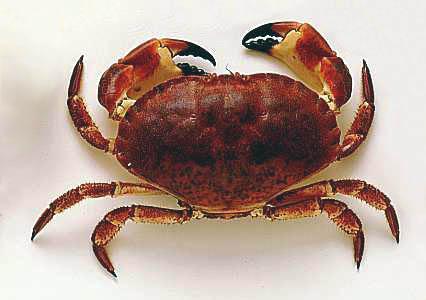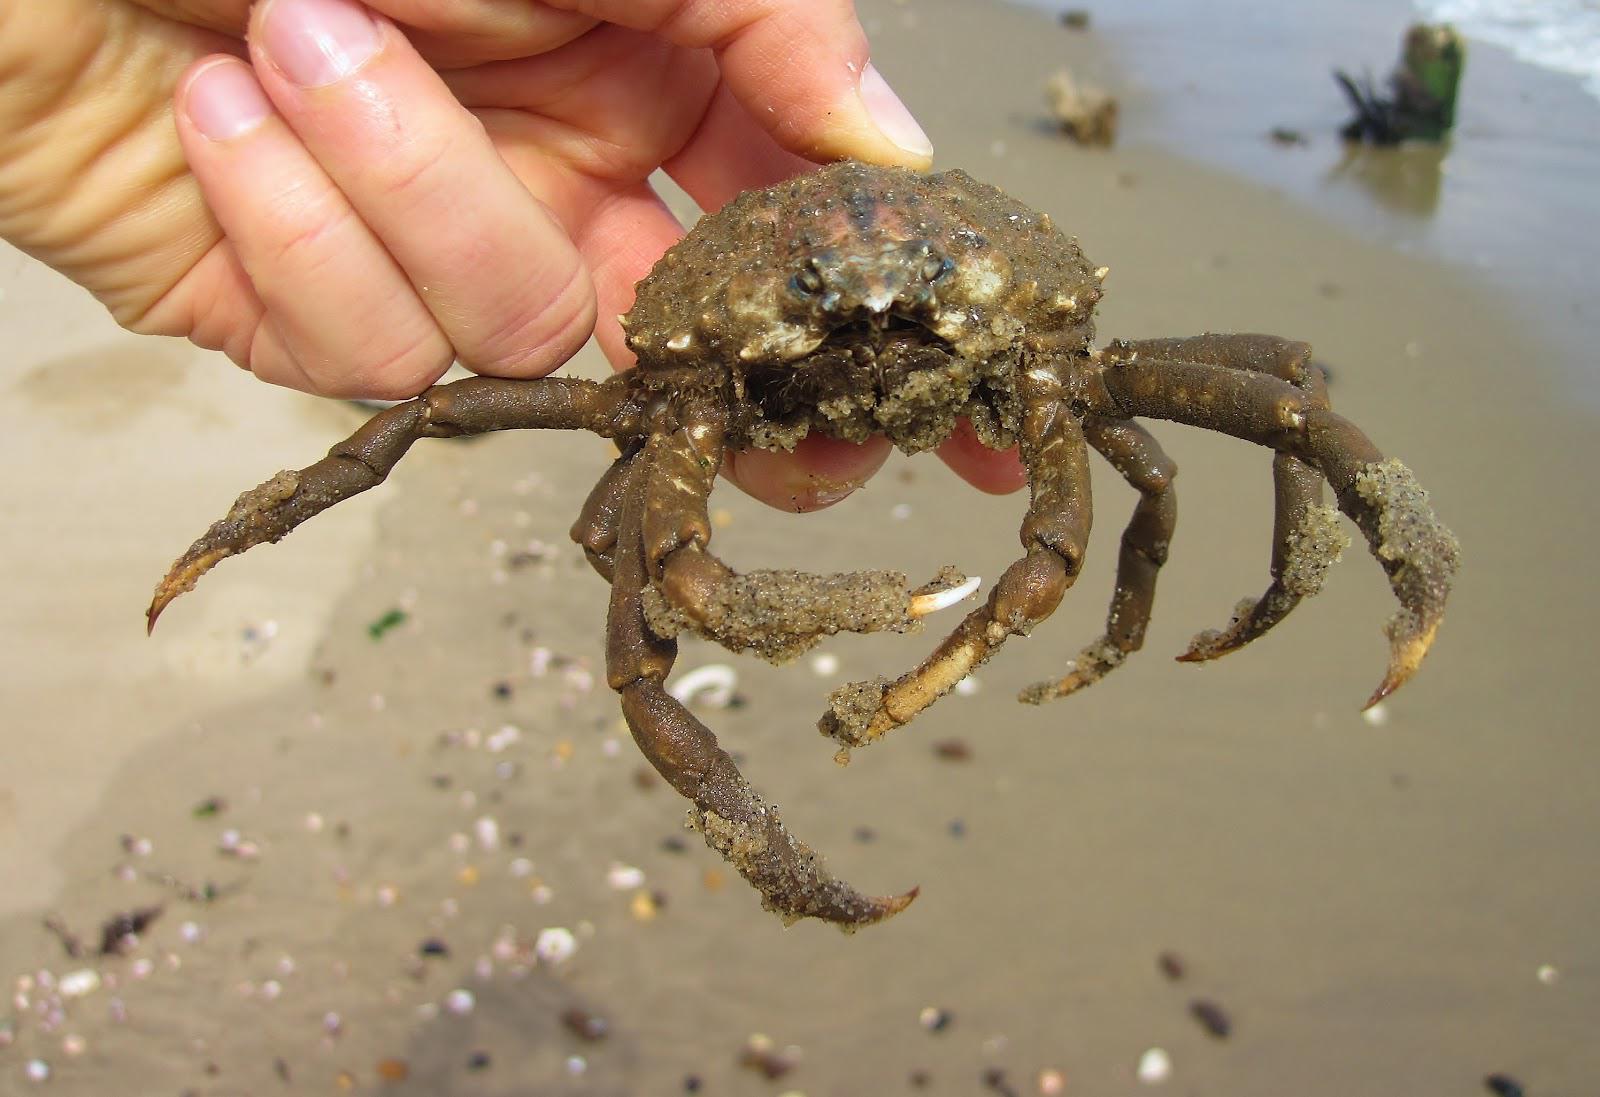The first image is the image on the left, the second image is the image on the right. Assess this claim about the two images: "The right image contains no more than one crab.". Correct or not? Answer yes or no. Yes. The first image is the image on the left, the second image is the image on the right. Given the left and right images, does the statement "The left and right images each show only one crab, and one of the pictured crabs is on a white background and has black-tipped front claws." hold true? Answer yes or no. Yes. 